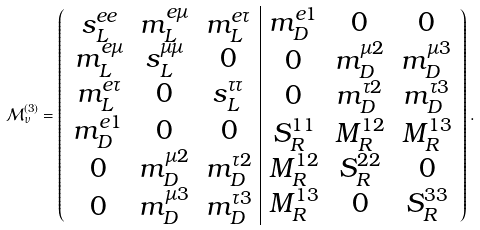<formula> <loc_0><loc_0><loc_500><loc_500>\mathcal { M } ^ { ( 3 ) } _ { \nu } = \begin{pmatrix} \begin{array} { c | c } \begin{matrix} s ^ { e e } _ { L } & m ^ { e \mu } _ { L } & m ^ { e \tau } _ { L } \\ m ^ { e \mu } _ { L } & s ^ { \mu \mu } _ { L } & 0 \\ m ^ { e \tau } _ { L } & 0 & s ^ { \tau \tau } _ { L } \end{matrix} & \begin{matrix} m ^ { e 1 } _ { D } & 0 & 0 \\ 0 & m ^ { \mu 2 } _ { D } & m ^ { \mu 3 } _ { D } \\ 0 & m ^ { \tau 2 } _ { D } & m ^ { \tau 3 } _ { D } \end{matrix} \\ \begin{matrix} m ^ { e 1 } _ { D } & 0 & 0 \\ 0 & m ^ { \mu 2 } _ { D } & m ^ { \tau 2 } _ { D } \\ 0 & m ^ { \mu 3 } _ { D } & m ^ { \tau 3 } _ { D } \end{matrix} & \begin{matrix} S ^ { 1 1 } _ { R } & M ^ { 1 2 } _ { R } & M ^ { 1 3 } _ { R } \\ M ^ { 1 2 } _ { R } & S ^ { 2 2 } _ { R } & 0 \\ M ^ { 1 3 } _ { R } & 0 & S ^ { 3 3 } _ { R } \end{matrix} \end{array} \end{pmatrix} .</formula> 